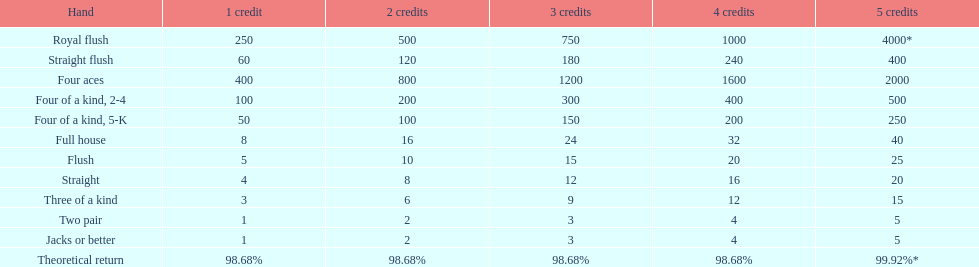The number of flush wins at one credit to equal one flush win at 5 credits. 5. 